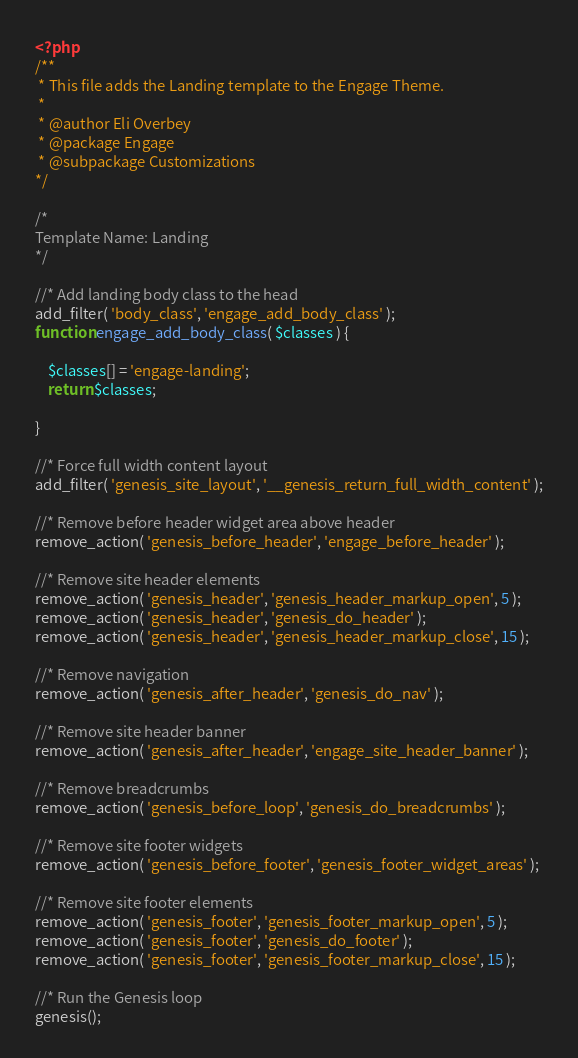Convert code to text. <code><loc_0><loc_0><loc_500><loc_500><_PHP_><?php
/**
 * This file adds the Landing template to the Engage Theme.
 *
 * @author Eli Overbey
 * @package Engage
 * @subpackage Customizations
*/

/*
Template Name: Landing
*/

//* Add landing body class to the head
add_filter( 'body_class', 'engage_add_body_class' );
function engage_add_body_class( $classes ) {

	$classes[] = 'engage-landing';
	return $classes;

}

//* Force full width content layout
add_filter( 'genesis_site_layout', '__genesis_return_full_width_content' );

//* Remove before header widget area above header
remove_action( 'genesis_before_header', 'engage_before_header' );

//* Remove site header elements
remove_action( 'genesis_header', 'genesis_header_markup_open', 5 );
remove_action( 'genesis_header', 'genesis_do_header' );
remove_action( 'genesis_header', 'genesis_header_markup_close', 15 );

//* Remove navigation
remove_action( 'genesis_after_header', 'genesis_do_nav' );

//* Remove site header banner
remove_action( 'genesis_after_header', 'engage_site_header_banner' );

//* Remove breadcrumbs
remove_action( 'genesis_before_loop', 'genesis_do_breadcrumbs' );

//* Remove site footer widgets
remove_action( 'genesis_before_footer', 'genesis_footer_widget_areas' );

//* Remove site footer elements
remove_action( 'genesis_footer', 'genesis_footer_markup_open', 5 );
remove_action( 'genesis_footer', 'genesis_do_footer' );
remove_action( 'genesis_footer', 'genesis_footer_markup_close', 15 );

//* Run the Genesis loop
genesis();
</code> 